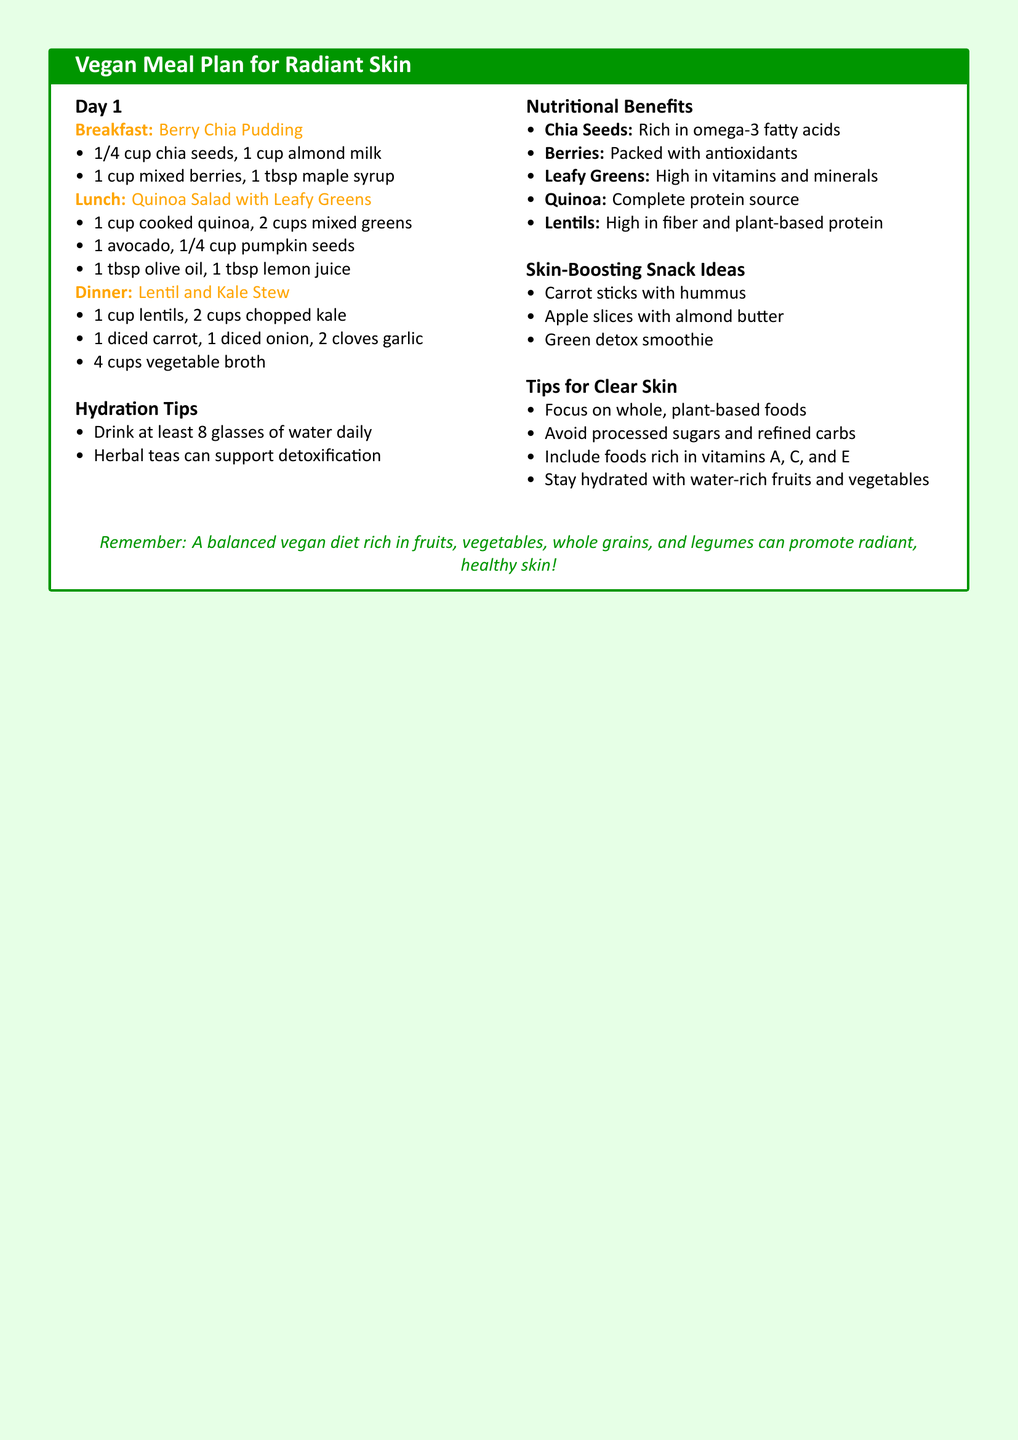What is the main title of the meal plan? The main title is the first text presented in the document, highlighting the focus of the meals.
Answer: Vegan Meal Plan for Radiant Skin What is the breakfast for Day 1? The breakfast is listed as the first meal in the Day 1 section of the document.
Answer: Berry Chia Pudding How many glasses of water should be consumed daily? The hydration tips section specifies the recommended amount of water to be consumed.
Answer: 8 glasses What is the primary source of omega-3 fatty acids in the meal plan? The nutritional benefits of the listed foods include specific nutrients, pointing to a particular item.
Answer: Chia Seeds What main benefit do berries provide according to the document? The benefits of different foods are listed, and berries are specifically mentioned for their properties.
Answer: Antioxidants What type of meal is Lentil and Kale Stew? The dinner section for Day 1 categorizes the meal type, giving clarity on the structure of the meal plan.
Answer: Dinner Which food group is emphasized for clear skin in the tips? The tips for clear skin mention a type of food to focus on for improved skin health.
Answer: Whole, plant-based foods How many meals are suggested for Day 1? The meals for Day 1 can be counted in the day's section, providing a clear answer.
Answer: 3 meals What snack is suggested that includes hummus? The skin-boosting snack ideas section names specific snacks to support skin health.
Answer: Carrot sticks with hummus 